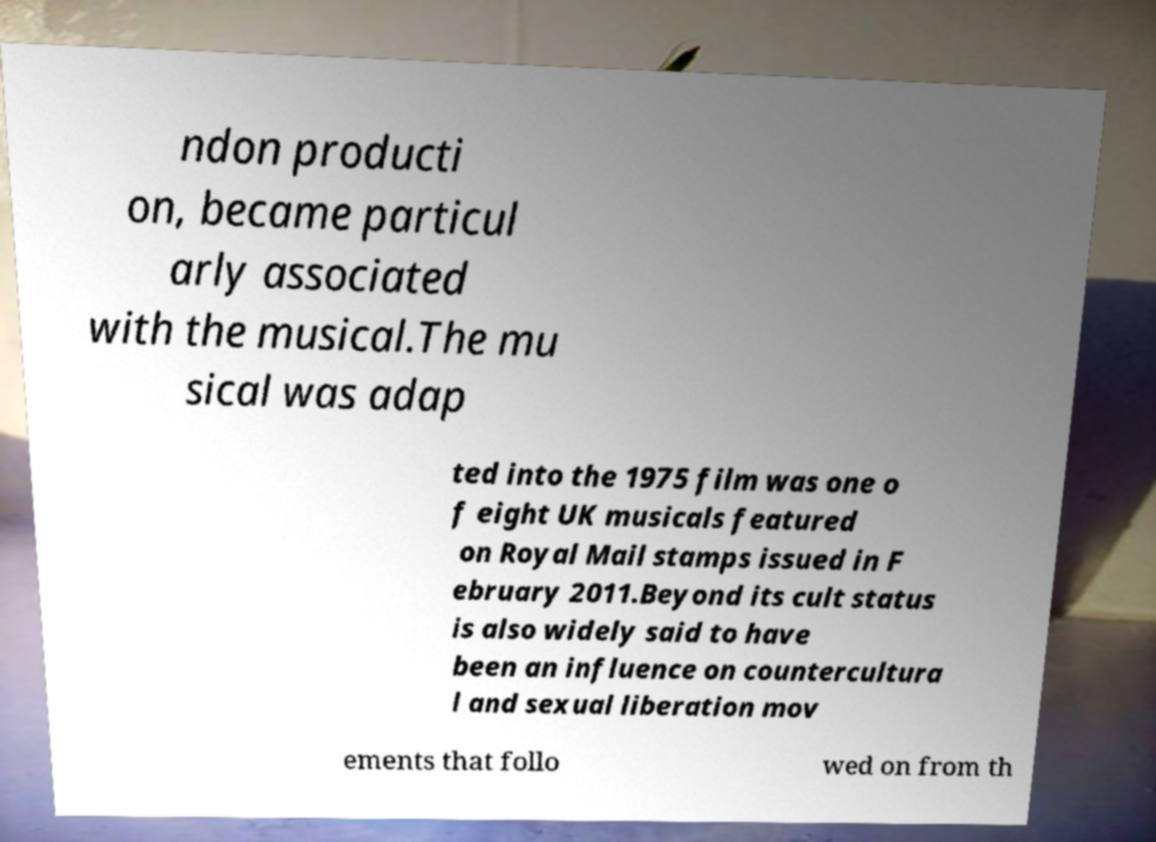What messages or text are displayed in this image? I need them in a readable, typed format. ndon producti on, became particul arly associated with the musical.The mu sical was adap ted into the 1975 film was one o f eight UK musicals featured on Royal Mail stamps issued in F ebruary 2011.Beyond its cult status is also widely said to have been an influence on countercultura l and sexual liberation mov ements that follo wed on from th 